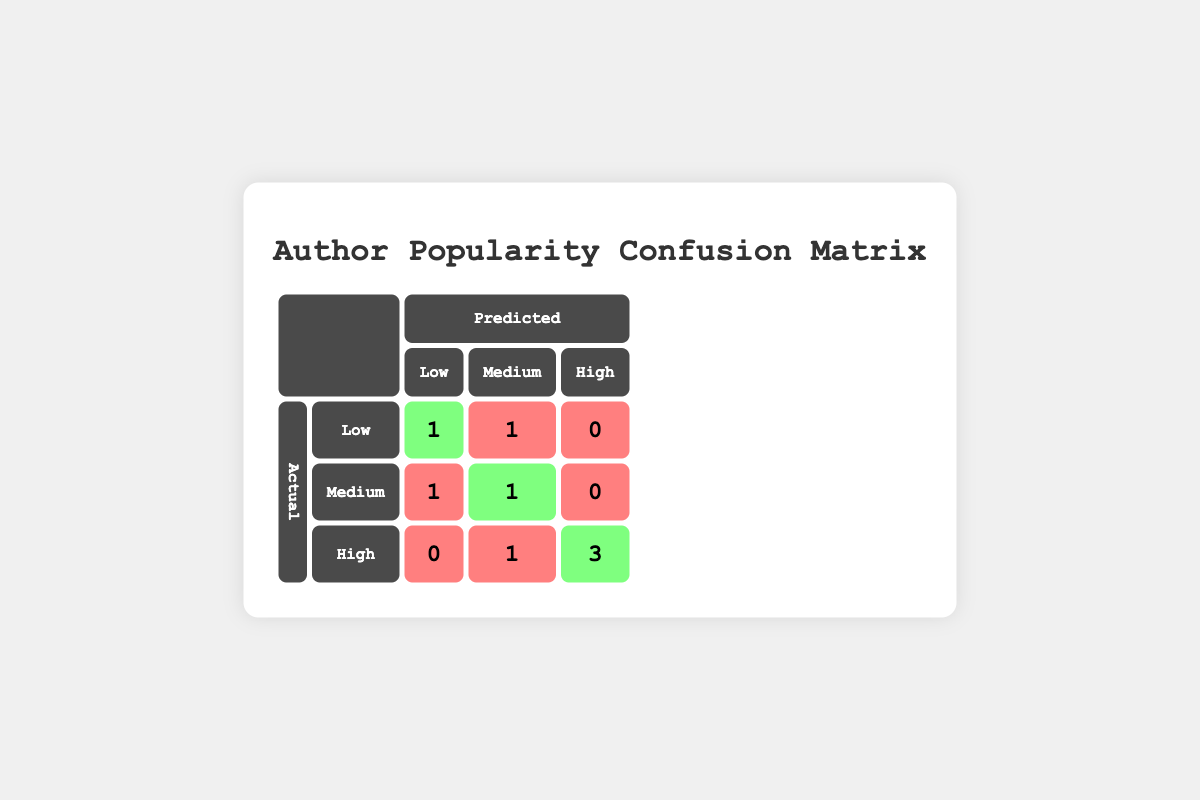What is the count of authors predicted to be "Low" in popularity who are actually "Low"? The table shows that for the predicted "Low" category, there is 1 author (Anne Rice) who is also in the actual "Low" category.
Answer: 1 How many authors are predicted to be "High" in popularity? Looking at the predicted "High" column, there are 4 authors (J.K. Rowling, Stephen King, Brandon Sanderson, and Colleen Hoover) predicted to be "High".
Answer: 4 What is the total number of authors with correct predictions for their popularity? The correct predictions are as follows: from the actual "Low" category 1, from the actual "Medium" category 1, and from the actual "High" category 3. Adding these counts gives us 1 + 1 + 3 = 5.
Answer: 5 Are there any authors with a predicted popularity of "High" who are actually "Low"? From the table, the predicted "High" category has 3 authors, and none are in the actual "Low" category, which indicates that the answer is no.
Answer: No What is the average social media engagement of authors who are actually categorized as "Medium" in popularity? The authors classified as "Medium" include Agatha Christie (2000) and Nora Roberts (6000), summing their engagements gives 2000 + 6000 = 8000. To find the average, we divide this sum by the number of authors, which is 2, yielding 8000 / 2 = 4000.
Answer: 4000 How many authors were incorrectly classified as having "Medium" predicted popularity while being actually "High"? The confusion matrix reveals that Colleen Hoover is the only author incorrectly classified as "Medium" while being "High," leading us to the conclusion of 1 author.
Answer: 1 What is the overall ratio of correct to incorrect predictions for authors in the "High" category? There are 3 correct predictions for "High" authors (Rowling, King, Sanderson) and 1 incorrect prediction (Colleen Hoover). This gives us a ratio of 3 to 1 for correct to incorrect predictions.
Answer: 3:1 How many authors were correctly predicted to be in the "Low" category? There is 1 author (Anne Rice) who is in the "Low" category with a correct prediction.
Answer: 1 